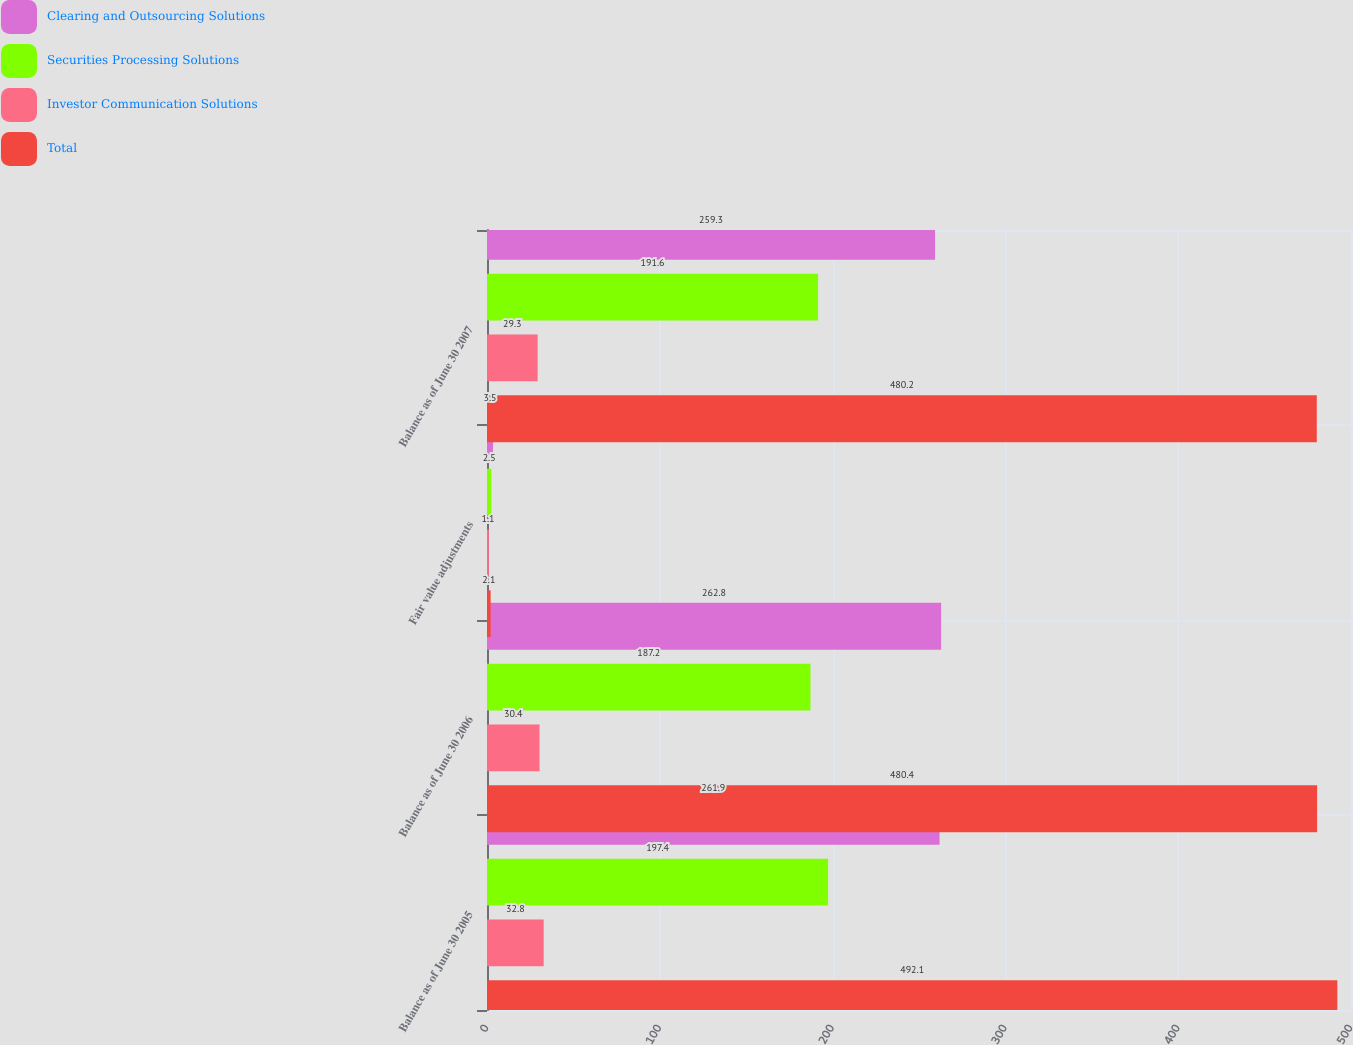<chart> <loc_0><loc_0><loc_500><loc_500><stacked_bar_chart><ecel><fcel>Balance as of June 30 2005<fcel>Balance as of June 30 2006<fcel>Fair value adjustments<fcel>Balance as of June 30 2007<nl><fcel>Clearing and Outsourcing Solutions<fcel>261.9<fcel>262.8<fcel>3.5<fcel>259.3<nl><fcel>Securities Processing Solutions<fcel>197.4<fcel>187.2<fcel>2.5<fcel>191.6<nl><fcel>Investor Communication Solutions<fcel>32.8<fcel>30.4<fcel>1.1<fcel>29.3<nl><fcel>Total<fcel>492.1<fcel>480.4<fcel>2.1<fcel>480.2<nl></chart> 